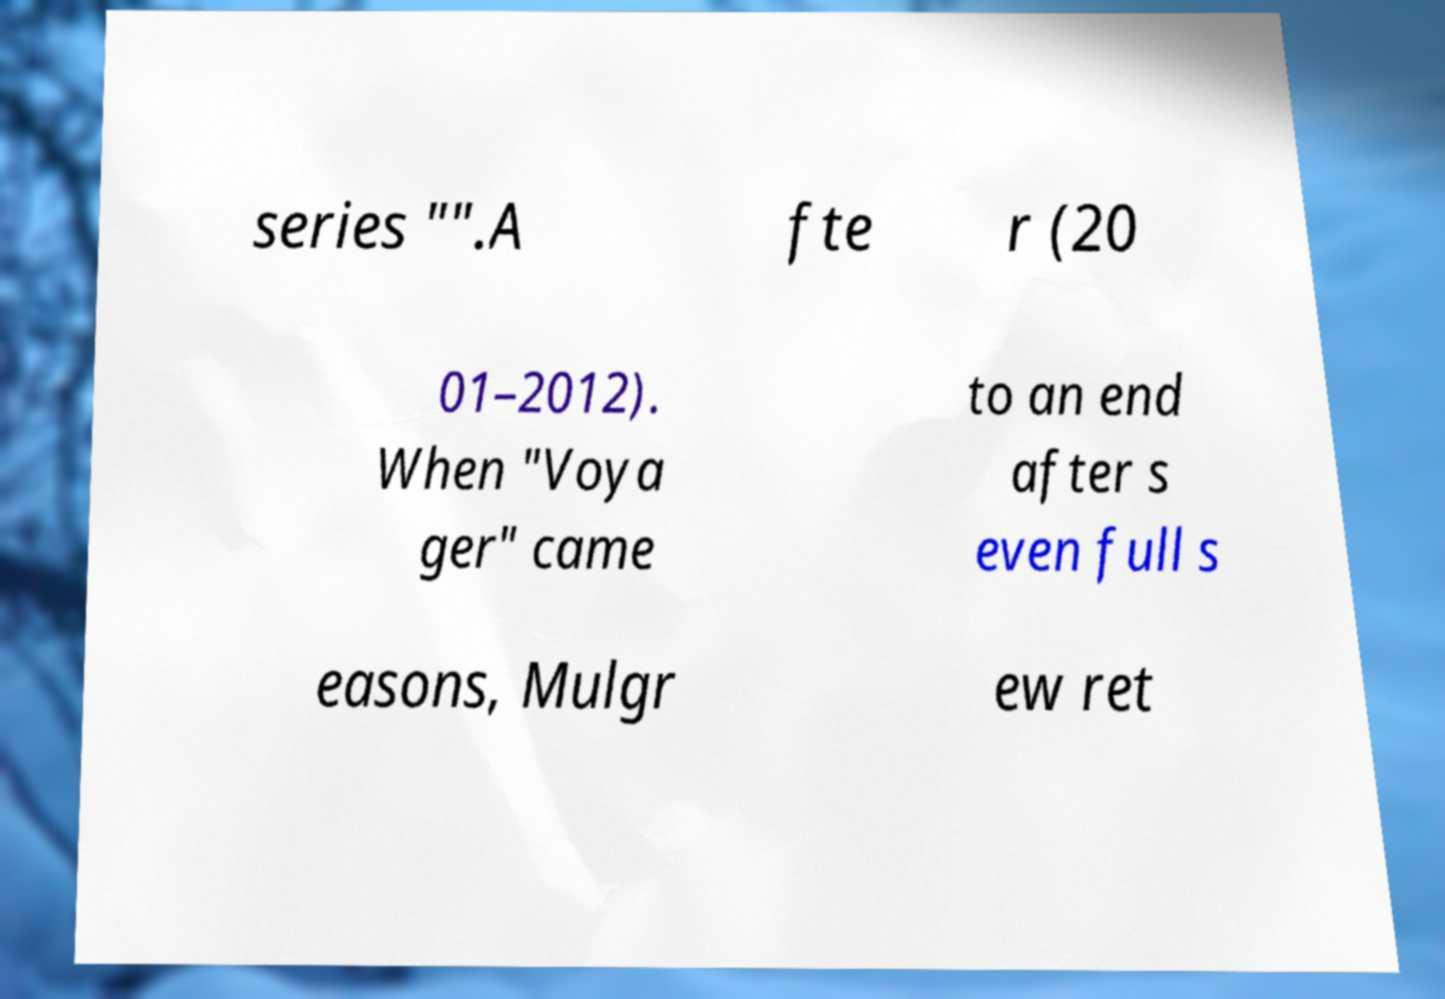I need the written content from this picture converted into text. Can you do that? series "".A fte r (20 01–2012). When "Voya ger" came to an end after s even full s easons, Mulgr ew ret 